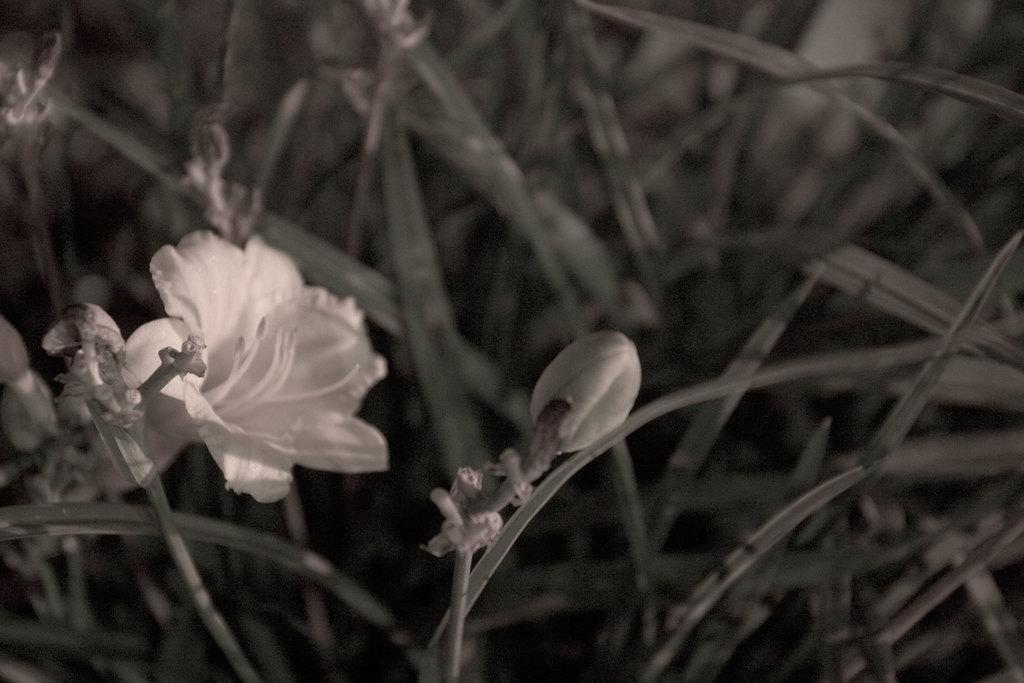How would you summarize this image in a sentence or two? In this image we can see some plants with flowers and buds. 